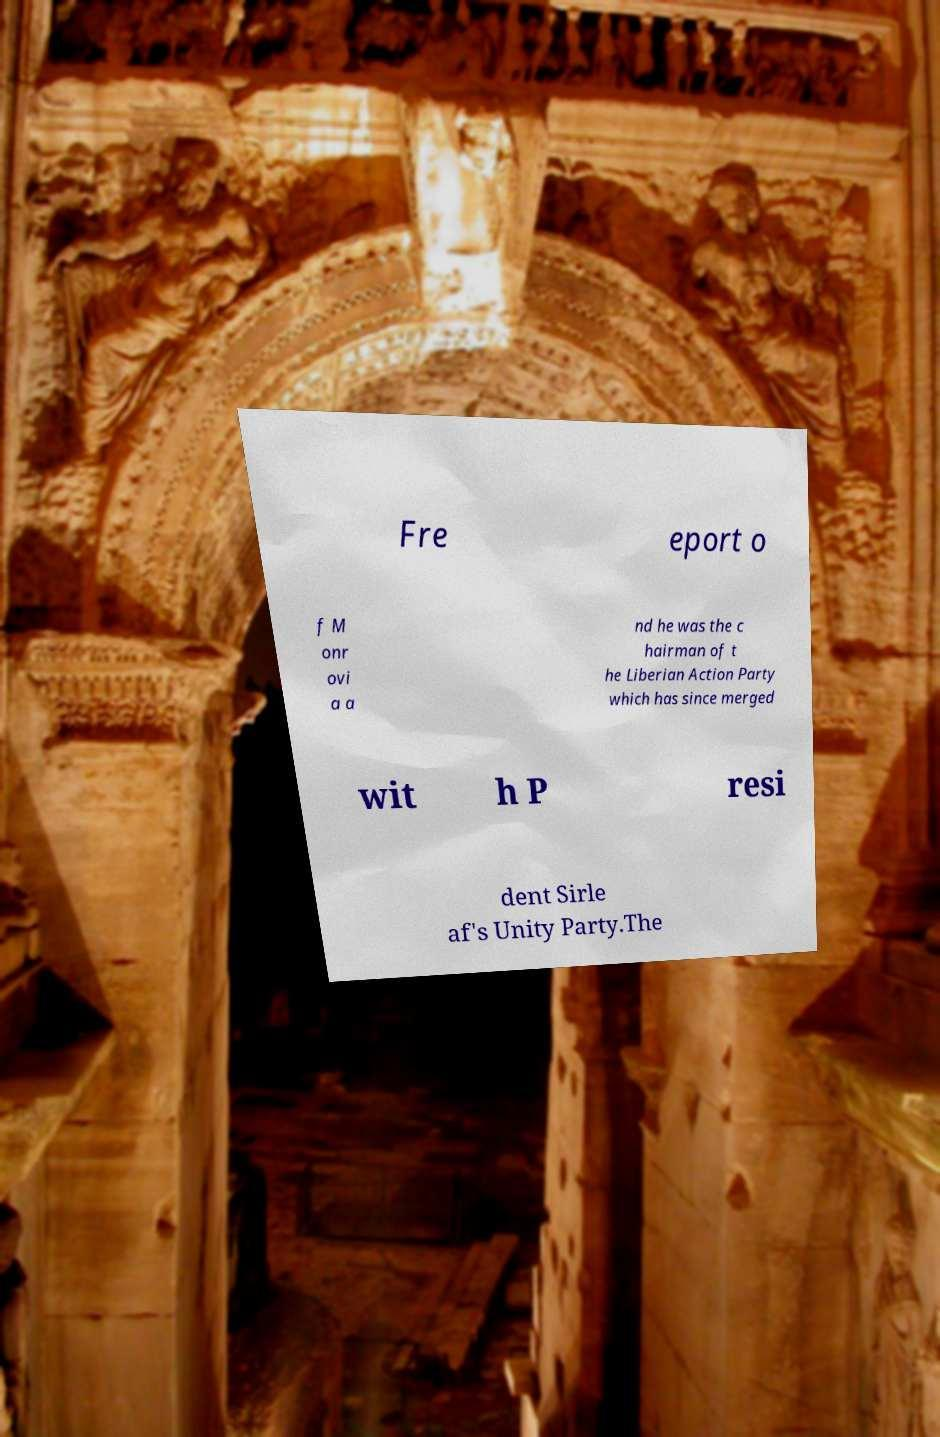Could you assist in decoding the text presented in this image and type it out clearly? Fre eport o f M onr ovi a a nd he was the c hairman of t he Liberian Action Party which has since merged wit h P resi dent Sirle af's Unity Party.The 